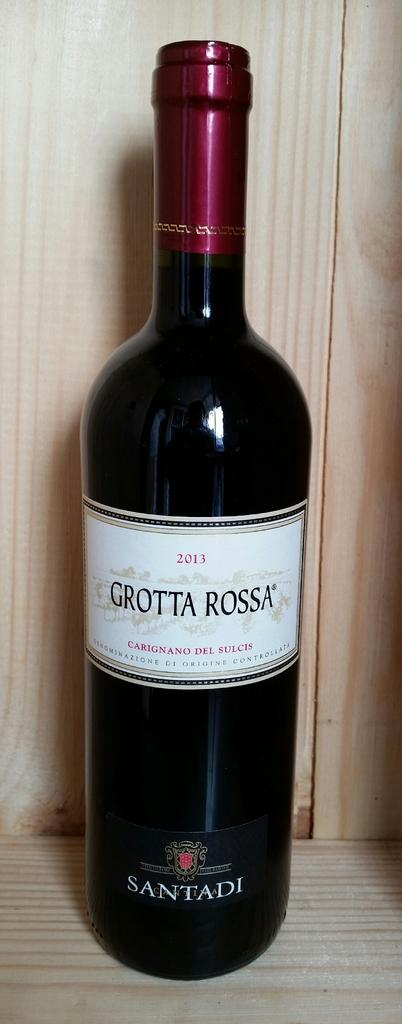<image>
Offer a succinct explanation of the picture presented. Bottle of Grotta Rossa placed on a wooden surface. 